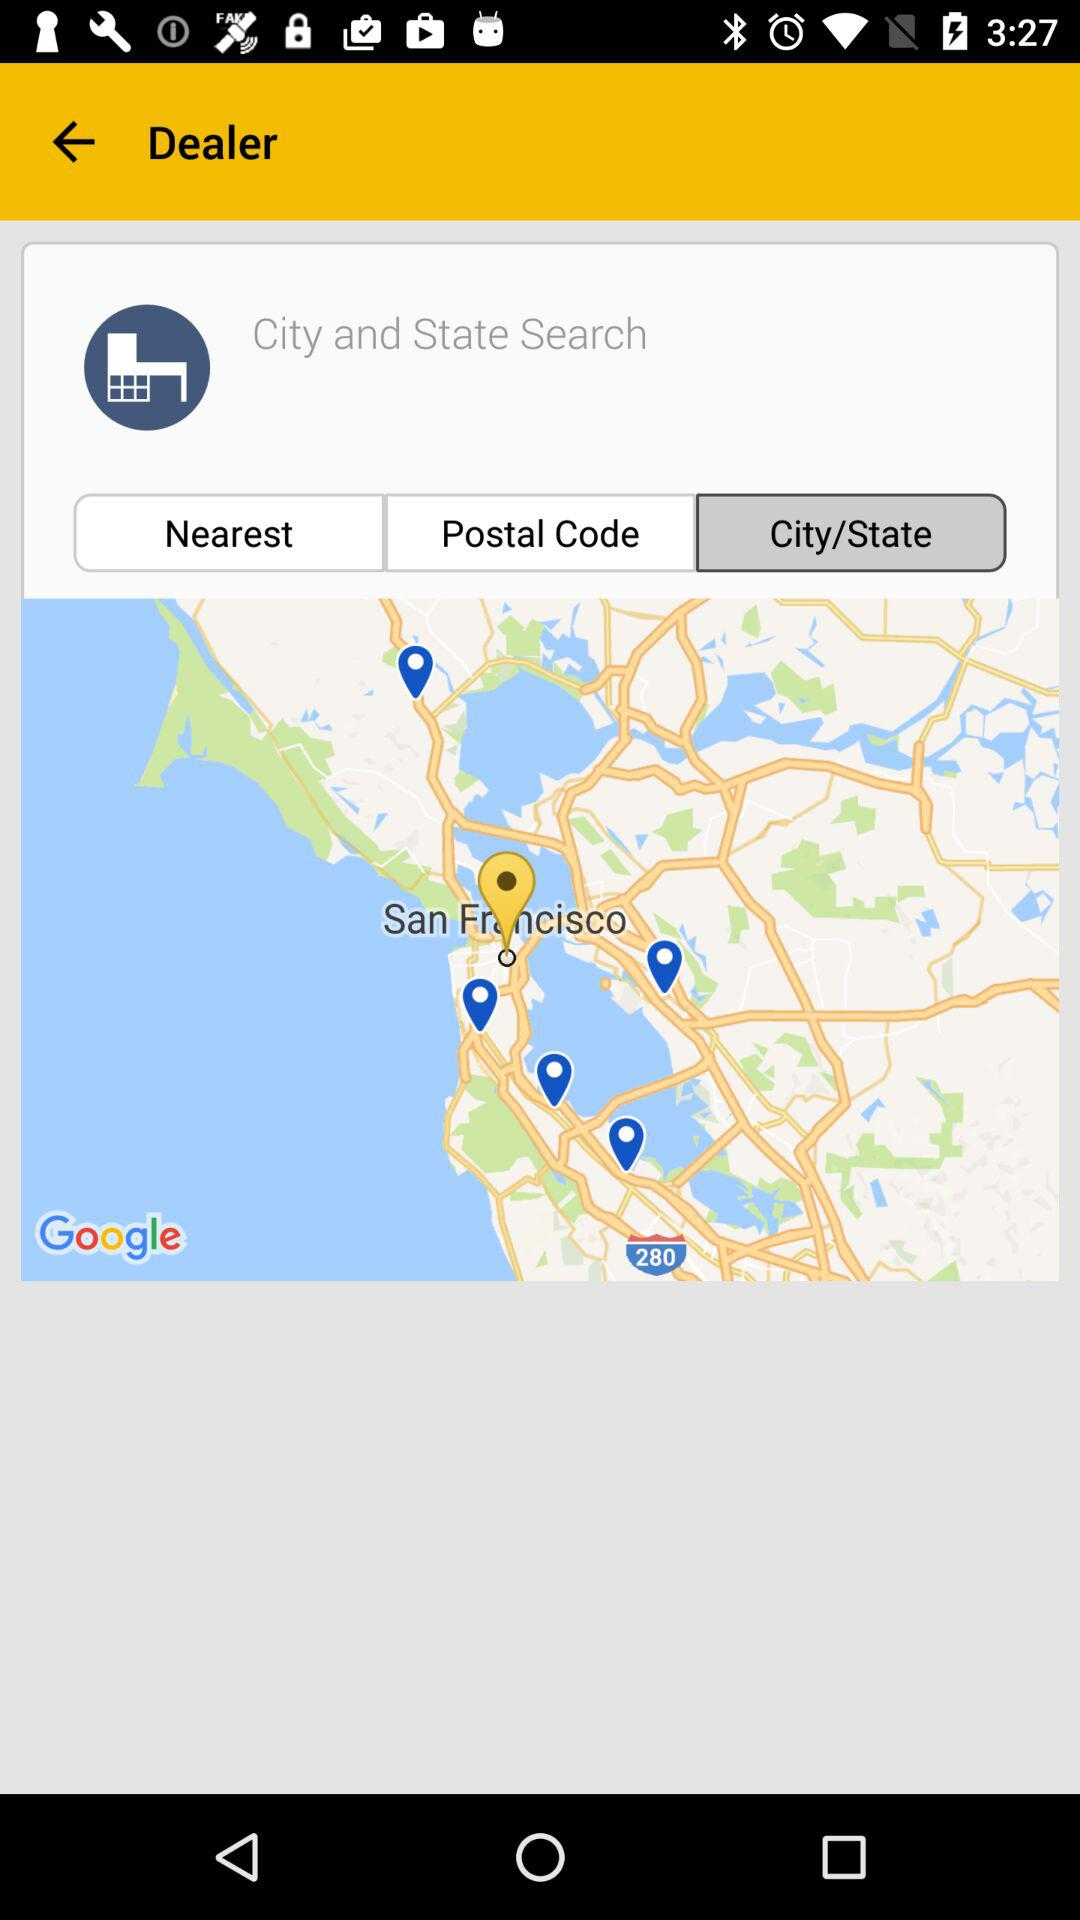Which tab is selected? The selected tab is "City/State". 